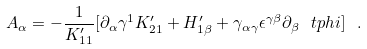Convert formula to latex. <formula><loc_0><loc_0><loc_500><loc_500>A _ { \alpha } = - \frac { 1 } { K ^ { \prime } _ { 1 1 } } [ \partial _ { \alpha } \gamma ^ { 1 } K _ { 2 1 } ^ { \prime } + H ^ { \prime } _ { 1 \beta } + \gamma _ { \alpha \gamma } \epsilon ^ { \gamma \beta } \partial _ { \beta } \ t p h i ] \ .</formula> 